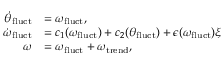<formula> <loc_0><loc_0><loc_500><loc_500>\begin{array} { r l } { \dot { \theta } _ { f l u c t } } & { = \omega _ { f l u c t } , } \\ { \dot { \omega } _ { f l u c t } } & { = c _ { 1 } ( \omega _ { f l u c t } ) + c _ { 2 } ( \theta _ { f l u c t } ) + \epsilon ( \omega _ { f l u c t } ) \xi } \\ { \omega } & { = \omega _ { f l u c t } + \omega _ { t r e n d } , } \end{array}</formula> 